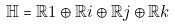<formula> <loc_0><loc_0><loc_500><loc_500>\mathbb { H } = \mathbb { R } 1 \oplus \mathbb { R } i \oplus \mathbb { R } j \oplus \mathbb { R } k</formula> 